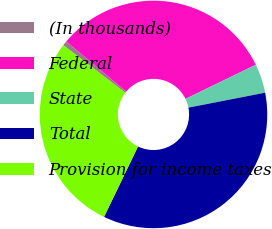Convert chart to OTSL. <chart><loc_0><loc_0><loc_500><loc_500><pie_chart><fcel>(In thousands)<fcel>Federal<fcel>State<fcel>Total<fcel>Provision for income taxes<nl><fcel>0.68%<fcel>31.71%<fcel>4.13%<fcel>35.22%<fcel>28.26%<nl></chart> 